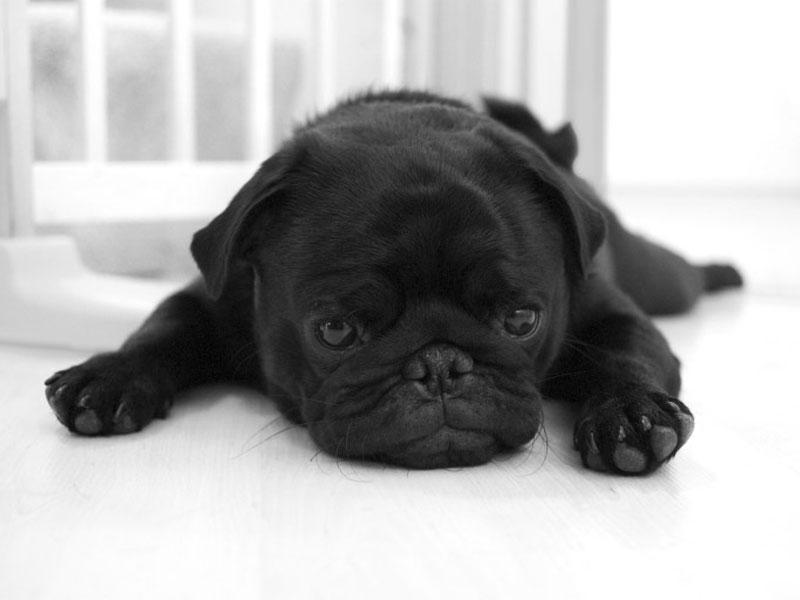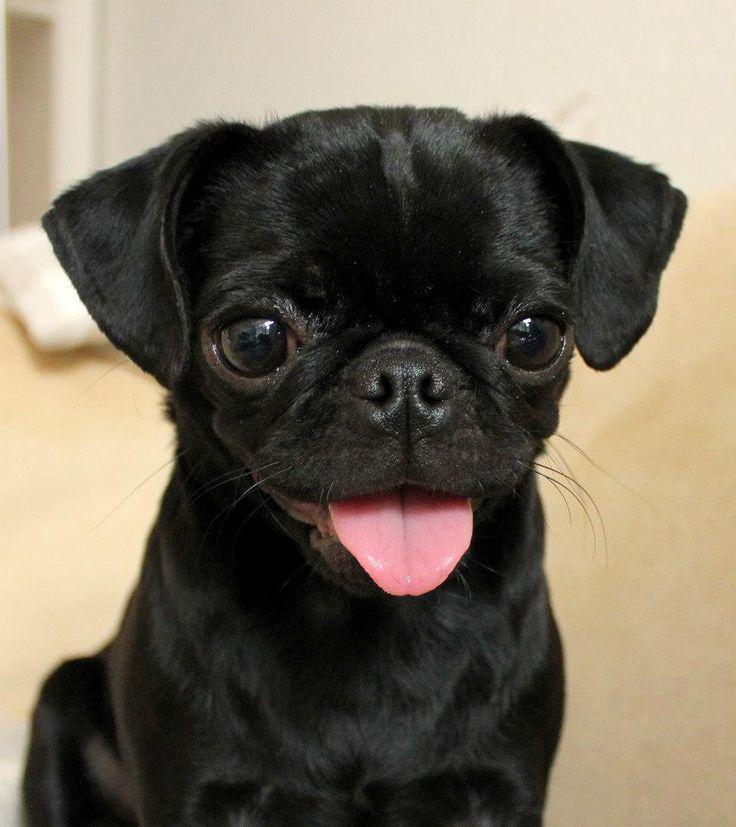The first image is the image on the left, the second image is the image on the right. Examine the images to the left and right. Is the description "An image shows one black pug, with its tongue out." accurate? Answer yes or no. Yes. The first image is the image on the left, the second image is the image on the right. For the images shown, is this caption "One of the dogs is standing in the grass." true? Answer yes or no. No. 